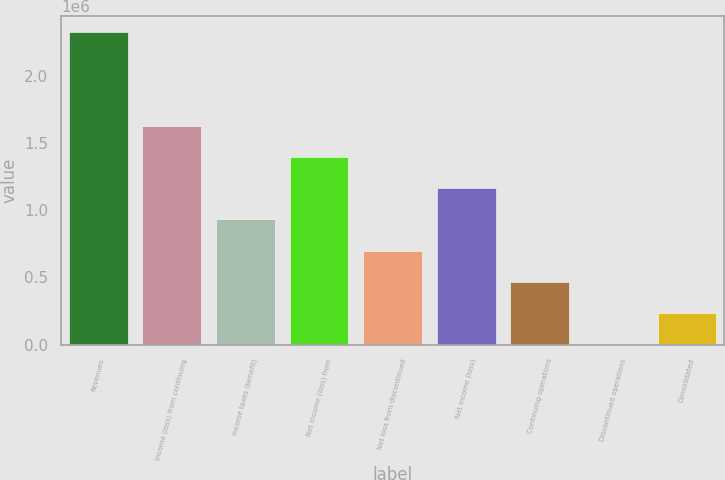Convert chart to OTSL. <chart><loc_0><loc_0><loc_500><loc_500><bar_chart><fcel>Revenues<fcel>Income (loss) from continuing<fcel>Income taxes (benefit)<fcel>Net income (loss) from<fcel>Net loss from discontinued<fcel>Net income (loss)<fcel>Continuing operations<fcel>Discontinued operations<fcel>Consolidated<nl><fcel>2.32792e+06<fcel>1.62954e+06<fcel>931166<fcel>1.39675e+06<fcel>698375<fcel>1.16396e+06<fcel>465583<fcel>0.02<fcel>232792<nl></chart> 